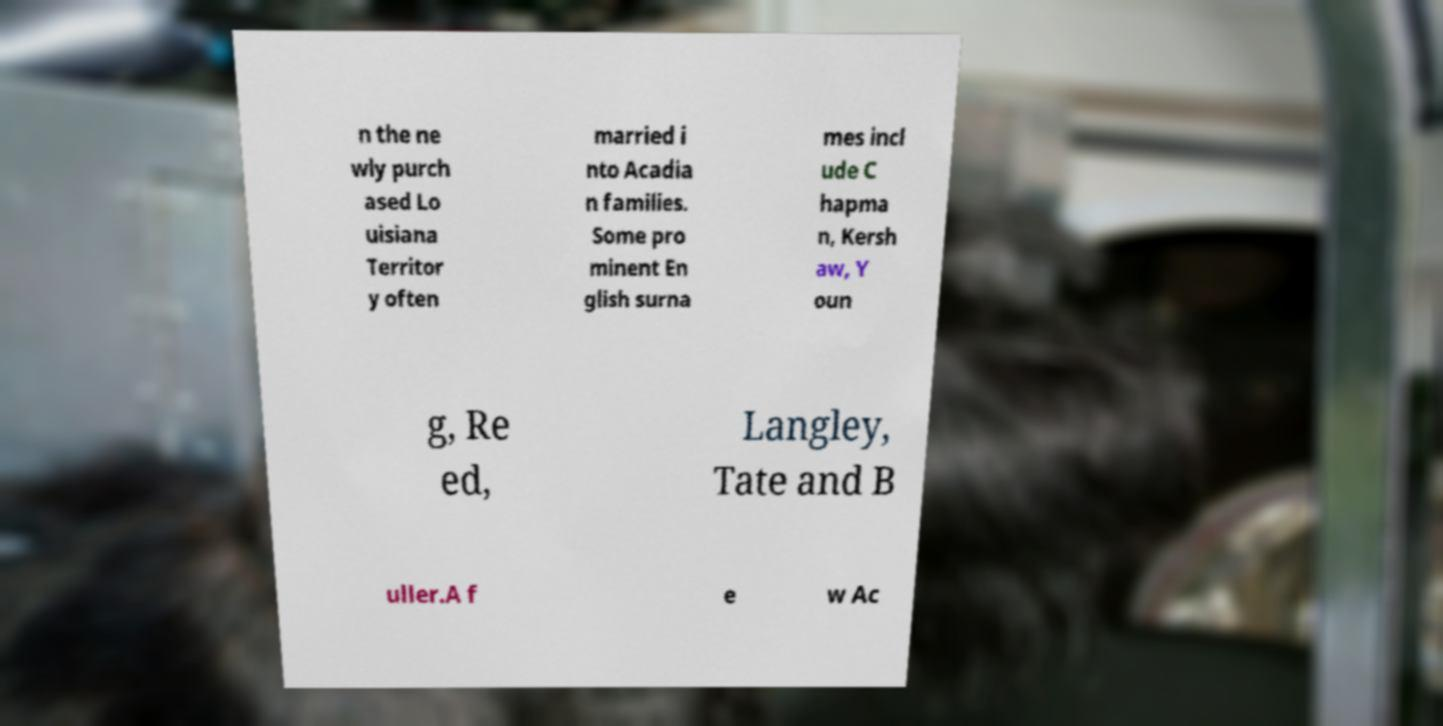What messages or text are displayed in this image? I need them in a readable, typed format. n the ne wly purch ased Lo uisiana Territor y often married i nto Acadia n families. Some pro minent En glish surna mes incl ude C hapma n, Kersh aw, Y oun g, Re ed, Langley, Tate and B uller.A f e w Ac 